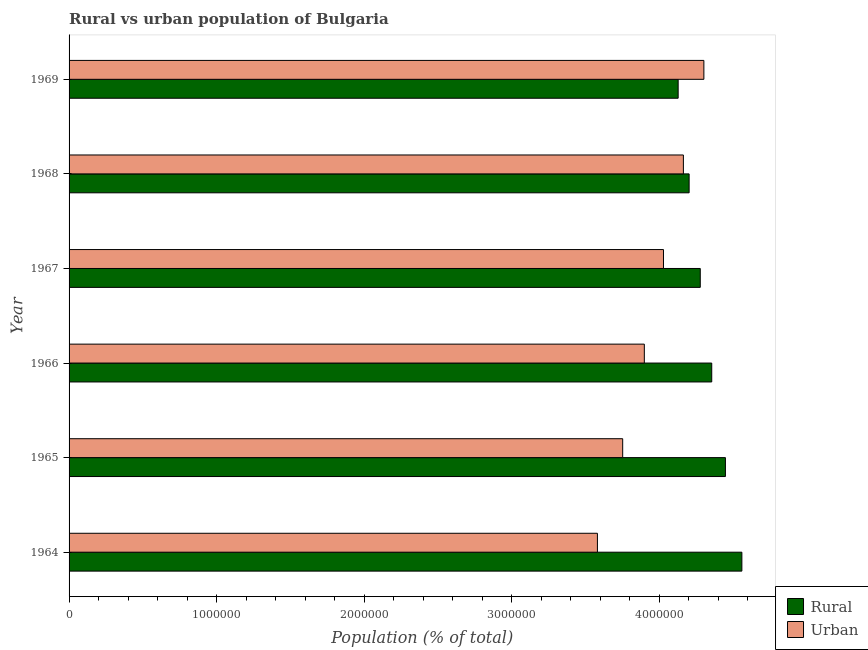How many different coloured bars are there?
Give a very brief answer. 2. How many groups of bars are there?
Provide a succinct answer. 6. Are the number of bars on each tick of the Y-axis equal?
Your answer should be compact. Yes. How many bars are there on the 3rd tick from the bottom?
Your answer should be very brief. 2. What is the label of the 5th group of bars from the top?
Provide a short and direct response. 1965. What is the rural population density in 1969?
Make the answer very short. 4.13e+06. Across all years, what is the maximum rural population density?
Your response must be concise. 4.56e+06. Across all years, what is the minimum rural population density?
Give a very brief answer. 4.13e+06. In which year was the urban population density maximum?
Your answer should be very brief. 1969. In which year was the rural population density minimum?
Your answer should be very brief. 1969. What is the total urban population density in the graph?
Offer a terse response. 2.37e+07. What is the difference between the rural population density in 1965 and that in 1969?
Provide a short and direct response. 3.20e+05. What is the difference between the rural population density in 1969 and the urban population density in 1965?
Make the answer very short. 3.76e+05. What is the average rural population density per year?
Make the answer very short. 4.33e+06. In the year 1964, what is the difference between the urban population density and rural population density?
Offer a very short reply. -9.79e+05. In how many years, is the rural population density greater than 2200000 %?
Your answer should be compact. 6. What is the ratio of the urban population density in 1964 to that in 1969?
Ensure brevity in your answer.  0.83. What is the difference between the highest and the second highest rural population density?
Offer a very short reply. 1.12e+05. What is the difference between the highest and the lowest urban population density?
Your response must be concise. 7.22e+05. What does the 1st bar from the top in 1966 represents?
Offer a very short reply. Urban. What does the 2nd bar from the bottom in 1967 represents?
Ensure brevity in your answer.  Urban. What is the difference between two consecutive major ticks on the X-axis?
Provide a short and direct response. 1.00e+06. Are the values on the major ticks of X-axis written in scientific E-notation?
Give a very brief answer. No. Does the graph contain any zero values?
Provide a succinct answer. No. Does the graph contain grids?
Ensure brevity in your answer.  No. How are the legend labels stacked?
Make the answer very short. Vertical. What is the title of the graph?
Ensure brevity in your answer.  Rural vs urban population of Bulgaria. Does "Under five" appear as one of the legend labels in the graph?
Provide a short and direct response. No. What is the label or title of the X-axis?
Make the answer very short. Population (% of total). What is the Population (% of total) in Rural in 1964?
Offer a very short reply. 4.56e+06. What is the Population (% of total) in Urban in 1964?
Your answer should be compact. 3.58e+06. What is the Population (% of total) of Rural in 1965?
Provide a succinct answer. 4.45e+06. What is the Population (% of total) of Urban in 1965?
Keep it short and to the point. 3.75e+06. What is the Population (% of total) in Rural in 1966?
Your response must be concise. 4.36e+06. What is the Population (% of total) in Urban in 1966?
Make the answer very short. 3.90e+06. What is the Population (% of total) in Rural in 1967?
Ensure brevity in your answer.  4.28e+06. What is the Population (% of total) of Urban in 1967?
Ensure brevity in your answer.  4.03e+06. What is the Population (% of total) in Rural in 1968?
Your response must be concise. 4.20e+06. What is the Population (% of total) in Urban in 1968?
Keep it short and to the point. 4.17e+06. What is the Population (% of total) of Rural in 1969?
Ensure brevity in your answer.  4.13e+06. What is the Population (% of total) in Urban in 1969?
Give a very brief answer. 4.30e+06. Across all years, what is the maximum Population (% of total) of Rural?
Provide a succinct answer. 4.56e+06. Across all years, what is the maximum Population (% of total) in Urban?
Ensure brevity in your answer.  4.30e+06. Across all years, what is the minimum Population (% of total) in Rural?
Your answer should be very brief. 4.13e+06. Across all years, what is the minimum Population (% of total) in Urban?
Make the answer very short. 3.58e+06. What is the total Population (% of total) of Rural in the graph?
Provide a short and direct response. 2.60e+07. What is the total Population (% of total) in Urban in the graph?
Ensure brevity in your answer.  2.37e+07. What is the difference between the Population (% of total) of Rural in 1964 and that in 1965?
Your answer should be compact. 1.12e+05. What is the difference between the Population (% of total) in Urban in 1964 and that in 1965?
Offer a terse response. -1.71e+05. What is the difference between the Population (% of total) in Rural in 1964 and that in 1966?
Provide a succinct answer. 2.04e+05. What is the difference between the Population (% of total) of Urban in 1964 and that in 1966?
Provide a succinct answer. -3.18e+05. What is the difference between the Population (% of total) in Rural in 1964 and that in 1967?
Offer a terse response. 2.82e+05. What is the difference between the Population (% of total) of Urban in 1964 and that in 1967?
Offer a very short reply. -4.48e+05. What is the difference between the Population (% of total) of Rural in 1964 and that in 1968?
Ensure brevity in your answer.  3.58e+05. What is the difference between the Population (% of total) of Urban in 1964 and that in 1968?
Your answer should be very brief. -5.83e+05. What is the difference between the Population (% of total) in Rural in 1964 and that in 1969?
Provide a short and direct response. 4.32e+05. What is the difference between the Population (% of total) in Urban in 1964 and that in 1969?
Keep it short and to the point. -7.22e+05. What is the difference between the Population (% of total) in Rural in 1965 and that in 1966?
Offer a terse response. 9.28e+04. What is the difference between the Population (% of total) of Urban in 1965 and that in 1966?
Provide a short and direct response. -1.47e+05. What is the difference between the Population (% of total) of Rural in 1965 and that in 1967?
Give a very brief answer. 1.71e+05. What is the difference between the Population (% of total) in Urban in 1965 and that in 1967?
Provide a succinct answer. -2.77e+05. What is the difference between the Population (% of total) of Rural in 1965 and that in 1968?
Offer a terse response. 2.46e+05. What is the difference between the Population (% of total) of Urban in 1965 and that in 1968?
Provide a short and direct response. -4.12e+05. What is the difference between the Population (% of total) in Rural in 1965 and that in 1969?
Keep it short and to the point. 3.20e+05. What is the difference between the Population (% of total) of Urban in 1965 and that in 1969?
Your answer should be very brief. -5.50e+05. What is the difference between the Population (% of total) in Rural in 1966 and that in 1967?
Keep it short and to the point. 7.77e+04. What is the difference between the Population (% of total) of Urban in 1966 and that in 1967?
Your answer should be compact. -1.30e+05. What is the difference between the Population (% of total) in Rural in 1966 and that in 1968?
Give a very brief answer. 1.53e+05. What is the difference between the Population (% of total) in Urban in 1966 and that in 1968?
Offer a terse response. -2.65e+05. What is the difference between the Population (% of total) of Rural in 1966 and that in 1969?
Keep it short and to the point. 2.28e+05. What is the difference between the Population (% of total) in Urban in 1966 and that in 1969?
Make the answer very short. -4.04e+05. What is the difference between the Population (% of total) of Rural in 1967 and that in 1968?
Give a very brief answer. 7.56e+04. What is the difference between the Population (% of total) in Urban in 1967 and that in 1968?
Give a very brief answer. -1.35e+05. What is the difference between the Population (% of total) of Rural in 1967 and that in 1969?
Offer a very short reply. 1.50e+05. What is the difference between the Population (% of total) of Urban in 1967 and that in 1969?
Offer a very short reply. -2.74e+05. What is the difference between the Population (% of total) in Rural in 1968 and that in 1969?
Offer a very short reply. 7.43e+04. What is the difference between the Population (% of total) of Urban in 1968 and that in 1969?
Give a very brief answer. -1.39e+05. What is the difference between the Population (% of total) in Rural in 1964 and the Population (% of total) in Urban in 1965?
Provide a short and direct response. 8.08e+05. What is the difference between the Population (% of total) of Rural in 1964 and the Population (% of total) of Urban in 1966?
Offer a terse response. 6.61e+05. What is the difference between the Population (% of total) in Rural in 1964 and the Population (% of total) in Urban in 1967?
Make the answer very short. 5.32e+05. What is the difference between the Population (% of total) of Rural in 1964 and the Population (% of total) of Urban in 1968?
Your answer should be very brief. 3.97e+05. What is the difference between the Population (% of total) in Rural in 1964 and the Population (% of total) in Urban in 1969?
Your answer should be very brief. 2.58e+05. What is the difference between the Population (% of total) of Rural in 1965 and the Population (% of total) of Urban in 1966?
Your answer should be very brief. 5.50e+05. What is the difference between the Population (% of total) in Rural in 1965 and the Population (% of total) in Urban in 1967?
Offer a very short reply. 4.20e+05. What is the difference between the Population (% of total) of Rural in 1965 and the Population (% of total) of Urban in 1968?
Give a very brief answer. 2.85e+05. What is the difference between the Population (% of total) of Rural in 1965 and the Population (% of total) of Urban in 1969?
Give a very brief answer. 1.46e+05. What is the difference between the Population (% of total) in Rural in 1966 and the Population (% of total) in Urban in 1967?
Your answer should be compact. 3.27e+05. What is the difference between the Population (% of total) of Rural in 1966 and the Population (% of total) of Urban in 1968?
Your response must be concise. 1.92e+05. What is the difference between the Population (% of total) in Rural in 1966 and the Population (% of total) in Urban in 1969?
Offer a very short reply. 5.32e+04. What is the difference between the Population (% of total) in Rural in 1967 and the Population (% of total) in Urban in 1968?
Ensure brevity in your answer.  1.14e+05. What is the difference between the Population (% of total) of Rural in 1967 and the Population (% of total) of Urban in 1969?
Give a very brief answer. -2.44e+04. What is the difference between the Population (% of total) of Rural in 1968 and the Population (% of total) of Urban in 1969?
Keep it short and to the point. -1.00e+05. What is the average Population (% of total) of Rural per year?
Ensure brevity in your answer.  4.33e+06. What is the average Population (% of total) of Urban per year?
Provide a succinct answer. 3.96e+06. In the year 1964, what is the difference between the Population (% of total) in Rural and Population (% of total) in Urban?
Keep it short and to the point. 9.79e+05. In the year 1965, what is the difference between the Population (% of total) in Rural and Population (% of total) in Urban?
Ensure brevity in your answer.  6.97e+05. In the year 1966, what is the difference between the Population (% of total) in Rural and Population (% of total) in Urban?
Your answer should be compact. 4.57e+05. In the year 1967, what is the difference between the Population (% of total) of Rural and Population (% of total) of Urban?
Your response must be concise. 2.49e+05. In the year 1968, what is the difference between the Population (% of total) in Rural and Population (% of total) in Urban?
Make the answer very short. 3.88e+04. In the year 1969, what is the difference between the Population (% of total) in Rural and Population (% of total) in Urban?
Provide a succinct answer. -1.74e+05. What is the ratio of the Population (% of total) of Rural in 1964 to that in 1965?
Offer a very short reply. 1.03. What is the ratio of the Population (% of total) of Urban in 1964 to that in 1965?
Make the answer very short. 0.95. What is the ratio of the Population (% of total) of Rural in 1964 to that in 1966?
Provide a short and direct response. 1.05. What is the ratio of the Population (% of total) in Urban in 1964 to that in 1966?
Make the answer very short. 0.92. What is the ratio of the Population (% of total) in Rural in 1964 to that in 1967?
Provide a short and direct response. 1.07. What is the ratio of the Population (% of total) in Urban in 1964 to that in 1967?
Offer a terse response. 0.89. What is the ratio of the Population (% of total) in Rural in 1964 to that in 1968?
Offer a terse response. 1.09. What is the ratio of the Population (% of total) in Urban in 1964 to that in 1968?
Provide a succinct answer. 0.86. What is the ratio of the Population (% of total) of Rural in 1964 to that in 1969?
Ensure brevity in your answer.  1.1. What is the ratio of the Population (% of total) in Urban in 1964 to that in 1969?
Give a very brief answer. 0.83. What is the ratio of the Population (% of total) in Rural in 1965 to that in 1966?
Ensure brevity in your answer.  1.02. What is the ratio of the Population (% of total) in Urban in 1965 to that in 1966?
Your answer should be very brief. 0.96. What is the ratio of the Population (% of total) of Rural in 1965 to that in 1967?
Your answer should be very brief. 1.04. What is the ratio of the Population (% of total) of Urban in 1965 to that in 1967?
Give a very brief answer. 0.93. What is the ratio of the Population (% of total) in Rural in 1965 to that in 1968?
Offer a terse response. 1.06. What is the ratio of the Population (% of total) in Urban in 1965 to that in 1968?
Provide a succinct answer. 0.9. What is the ratio of the Population (% of total) of Rural in 1965 to that in 1969?
Offer a very short reply. 1.08. What is the ratio of the Population (% of total) of Urban in 1965 to that in 1969?
Keep it short and to the point. 0.87. What is the ratio of the Population (% of total) of Rural in 1966 to that in 1967?
Offer a terse response. 1.02. What is the ratio of the Population (% of total) in Urban in 1966 to that in 1967?
Provide a short and direct response. 0.97. What is the ratio of the Population (% of total) of Rural in 1966 to that in 1968?
Keep it short and to the point. 1.04. What is the ratio of the Population (% of total) in Urban in 1966 to that in 1968?
Your answer should be very brief. 0.94. What is the ratio of the Population (% of total) of Rural in 1966 to that in 1969?
Provide a succinct answer. 1.06. What is the ratio of the Population (% of total) of Urban in 1966 to that in 1969?
Provide a short and direct response. 0.91. What is the ratio of the Population (% of total) of Rural in 1967 to that in 1968?
Make the answer very short. 1.02. What is the ratio of the Population (% of total) of Urban in 1967 to that in 1968?
Your response must be concise. 0.97. What is the ratio of the Population (% of total) in Rural in 1967 to that in 1969?
Provide a succinct answer. 1.04. What is the ratio of the Population (% of total) of Urban in 1967 to that in 1969?
Your response must be concise. 0.94. What is the ratio of the Population (% of total) in Rural in 1968 to that in 1969?
Provide a succinct answer. 1.02. What is the ratio of the Population (% of total) in Urban in 1968 to that in 1969?
Offer a very short reply. 0.97. What is the difference between the highest and the second highest Population (% of total) in Rural?
Your response must be concise. 1.12e+05. What is the difference between the highest and the second highest Population (% of total) in Urban?
Make the answer very short. 1.39e+05. What is the difference between the highest and the lowest Population (% of total) in Rural?
Provide a short and direct response. 4.32e+05. What is the difference between the highest and the lowest Population (% of total) of Urban?
Provide a short and direct response. 7.22e+05. 